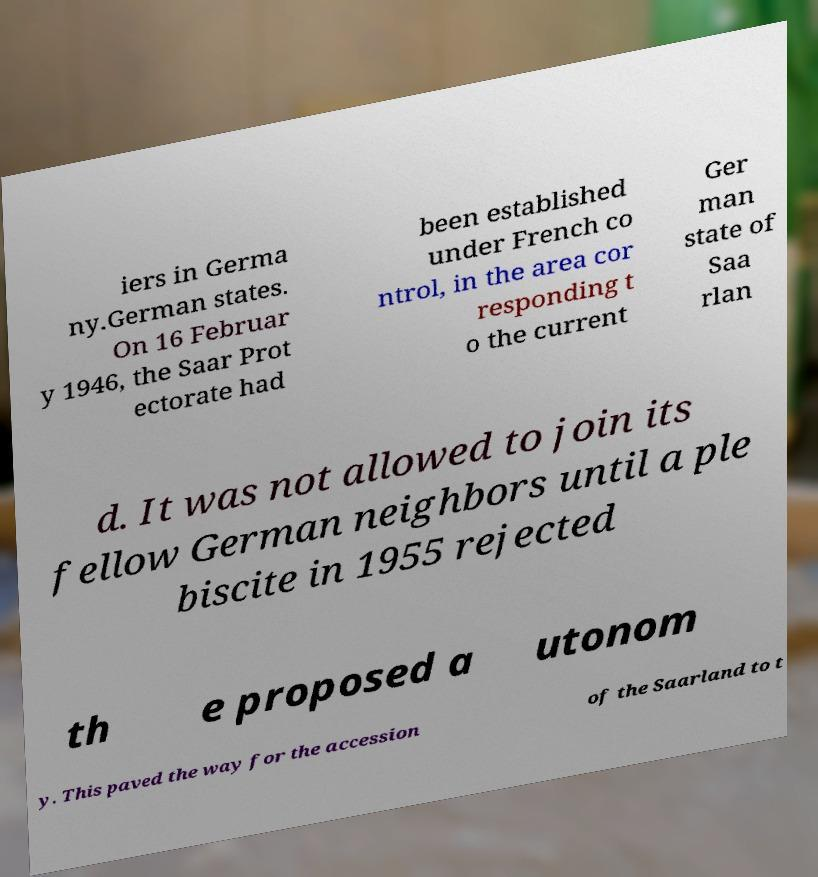Please read and relay the text visible in this image. What does it say? iers in Germa ny.German states. On 16 Februar y 1946, the Saar Prot ectorate had been established under French co ntrol, in the area cor responding t o the current Ger man state of Saa rlan d. It was not allowed to join its fellow German neighbors until a ple biscite in 1955 rejected th e proposed a utonom y. This paved the way for the accession of the Saarland to t 